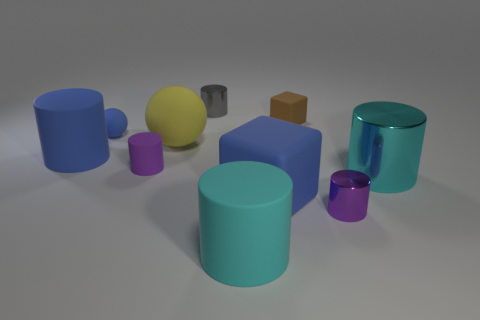Subtract all purple rubber cylinders. How many cylinders are left? 5 Subtract all blue cylinders. How many cylinders are left? 5 Subtract 2 cylinders. How many cylinders are left? 4 Subtract all brown spheres. How many purple cylinders are left? 2 Subtract all cylinders. How many objects are left? 4 Subtract all large brown cubes. Subtract all blue rubber spheres. How many objects are left? 9 Add 8 gray cylinders. How many gray cylinders are left? 9 Add 8 large yellow cylinders. How many large yellow cylinders exist? 8 Subtract 0 red balls. How many objects are left? 10 Subtract all blue cylinders. Subtract all blue spheres. How many cylinders are left? 5 